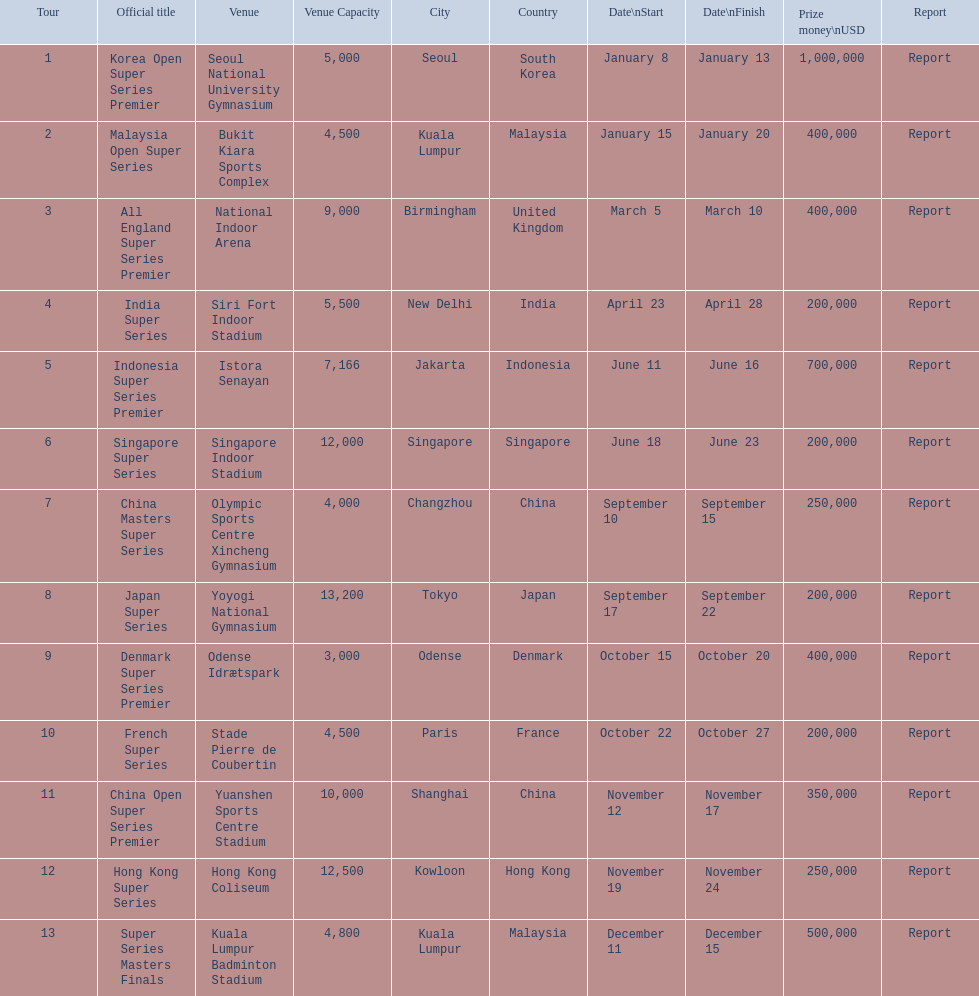Which tournament shares the same prize money amount as the french super series? Japan Super Series, Singapore Super Series, India Super Series. 